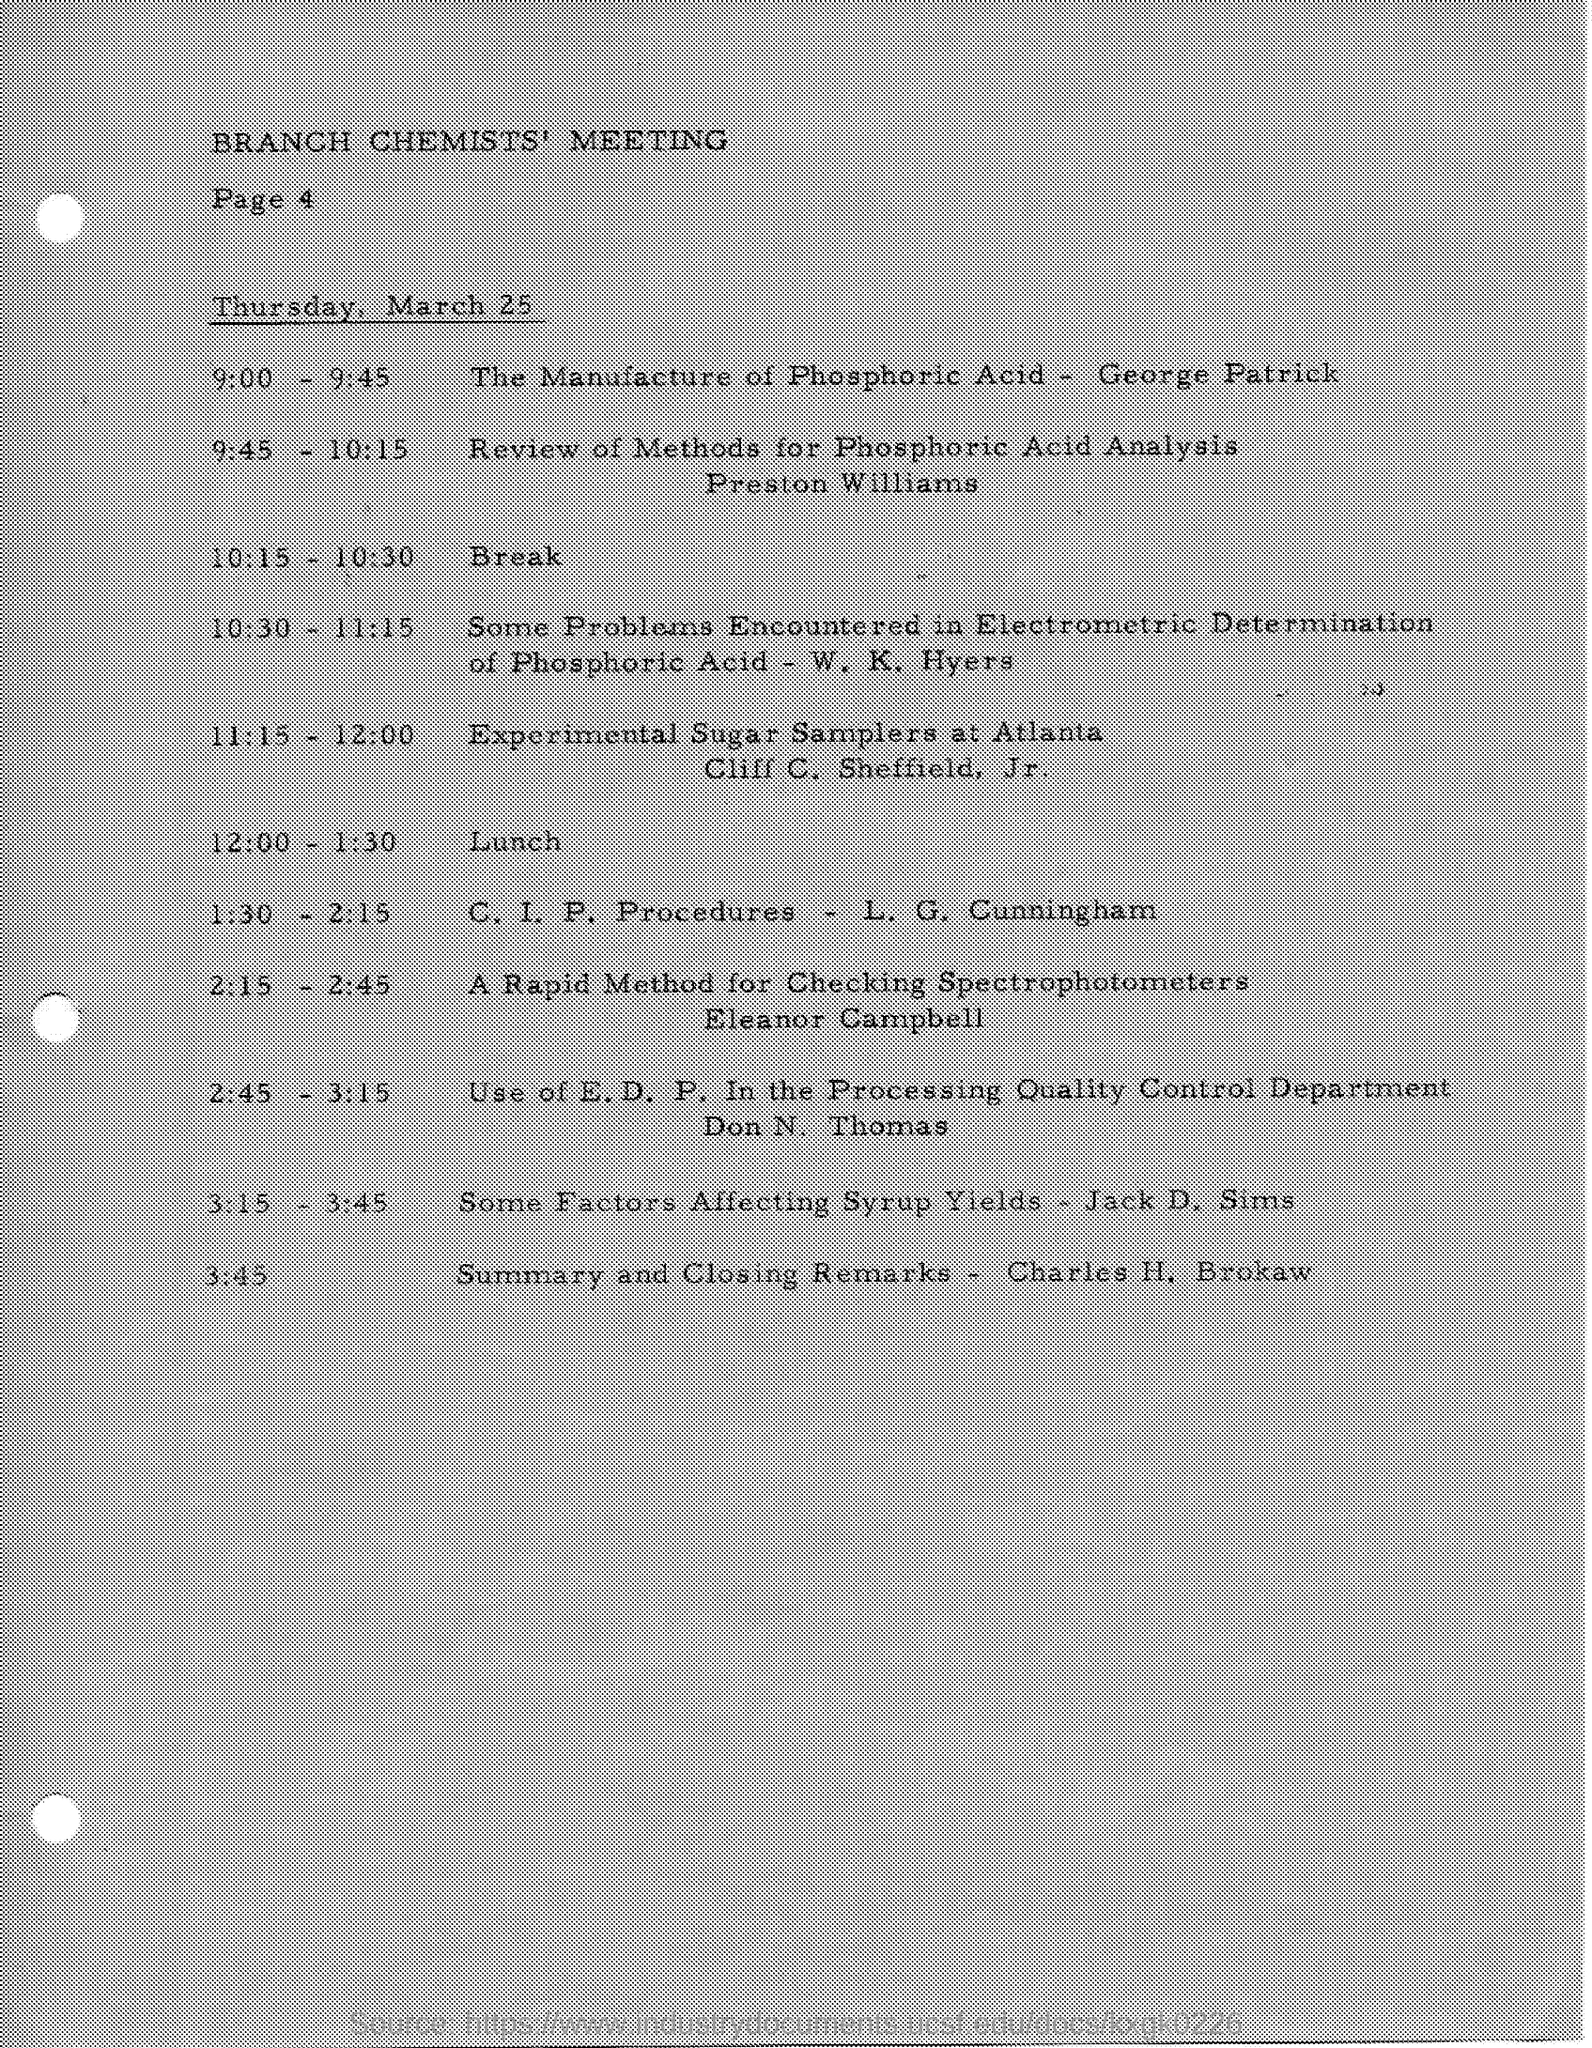Can you explain what might be covered during the presentation by Preston Williams on phosphoric acid analysis? Preston Williams' presentation on phosphoric acid analysis potentially included a detailed discussion on various analytical techniques, the importance of accurate measurements, and possibly the introduction of new methodologies or improvements in existing ones relevant to chemical industries. 